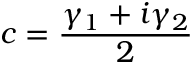Convert formula to latex. <formula><loc_0><loc_0><loc_500><loc_500>c = \frac { \gamma _ { 1 } + i \gamma _ { 2 } } { 2 }</formula> 